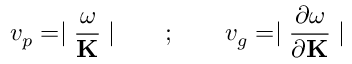<formula> <loc_0><loc_0><loc_500><loc_500>v _ { p } = | \frac { \omega } { K } | \quad ; \quad v _ { g } = | \frac { \partial \omega } { \partial { K } } |</formula> 